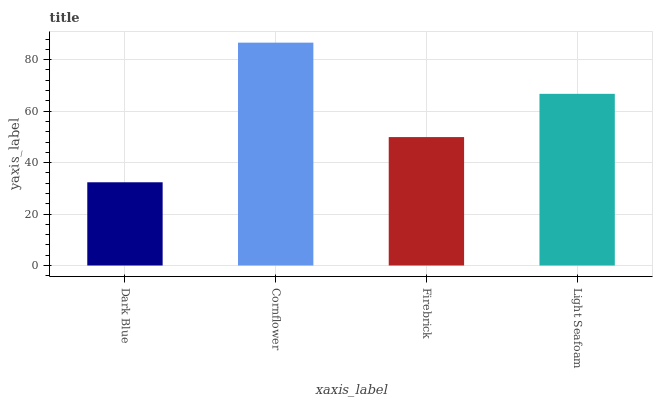Is Dark Blue the minimum?
Answer yes or no. Yes. Is Cornflower the maximum?
Answer yes or no. Yes. Is Firebrick the minimum?
Answer yes or no. No. Is Firebrick the maximum?
Answer yes or no. No. Is Cornflower greater than Firebrick?
Answer yes or no. Yes. Is Firebrick less than Cornflower?
Answer yes or no. Yes. Is Firebrick greater than Cornflower?
Answer yes or no. No. Is Cornflower less than Firebrick?
Answer yes or no. No. Is Light Seafoam the high median?
Answer yes or no. Yes. Is Firebrick the low median?
Answer yes or no. Yes. Is Cornflower the high median?
Answer yes or no. No. Is Dark Blue the low median?
Answer yes or no. No. 